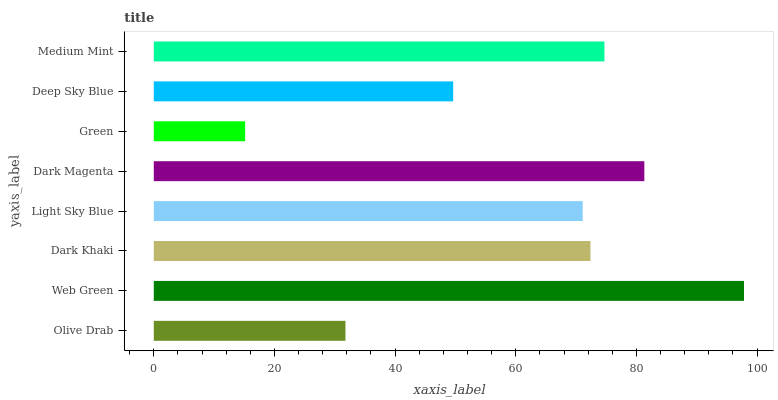Is Green the minimum?
Answer yes or no. Yes. Is Web Green the maximum?
Answer yes or no. Yes. Is Dark Khaki the minimum?
Answer yes or no. No. Is Dark Khaki the maximum?
Answer yes or no. No. Is Web Green greater than Dark Khaki?
Answer yes or no. Yes. Is Dark Khaki less than Web Green?
Answer yes or no. Yes. Is Dark Khaki greater than Web Green?
Answer yes or no. No. Is Web Green less than Dark Khaki?
Answer yes or no. No. Is Dark Khaki the high median?
Answer yes or no. Yes. Is Light Sky Blue the low median?
Answer yes or no. Yes. Is Light Sky Blue the high median?
Answer yes or no. No. Is Deep Sky Blue the low median?
Answer yes or no. No. 